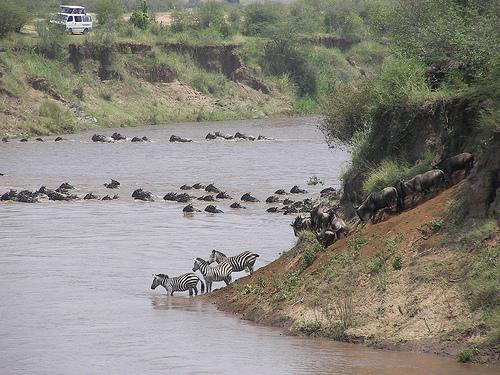How many zebras are there?
Give a very brief answer. 3. 